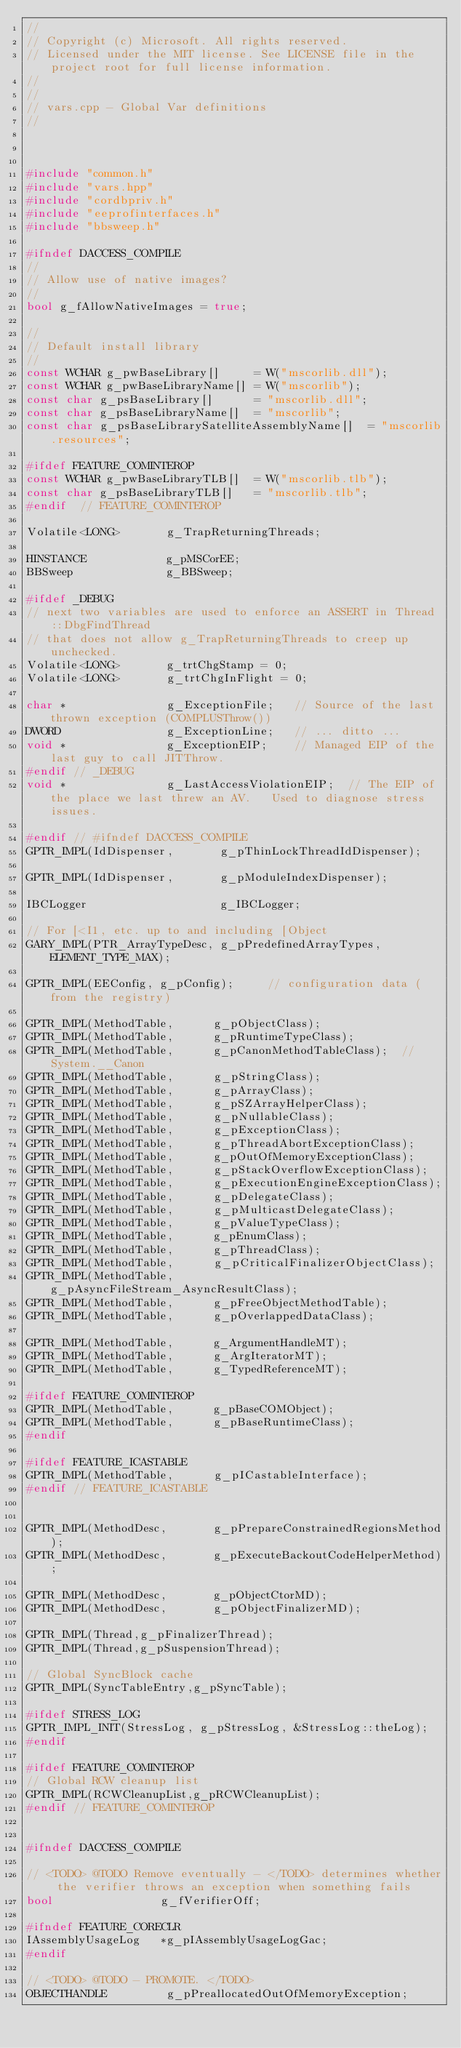Convert code to text. <code><loc_0><loc_0><loc_500><loc_500><_C++_>//
// Copyright (c) Microsoft. All rights reserved.
// Licensed under the MIT license. See LICENSE file in the project root for full license information.
//
//
// vars.cpp - Global Var definitions
//



#include "common.h"
#include "vars.hpp"
#include "cordbpriv.h"
#include "eeprofinterfaces.h"
#include "bbsweep.h"

#ifndef DACCESS_COMPILE
//
// Allow use of native images?
//
bool g_fAllowNativeImages = true;

//
// Default install library
//
const WCHAR g_pwBaseLibrary[]     = W("mscorlib.dll");
const WCHAR g_pwBaseLibraryName[] = W("mscorlib");
const char g_psBaseLibrary[]      = "mscorlib.dll";
const char g_psBaseLibraryName[]  = "mscorlib";
const char g_psBaseLibrarySatelliteAssemblyName[]  = "mscorlib.resources";

#ifdef FEATURE_COMINTEROP
const WCHAR g_pwBaseLibraryTLB[]  = W("mscorlib.tlb");
const char g_psBaseLibraryTLB[]   = "mscorlib.tlb";
#endif  // FEATURE_COMINTEROP

Volatile<LONG>       g_TrapReturningThreads;

HINSTANCE            g_pMSCorEE;
BBSweep              g_BBSweep;

#ifdef _DEBUG
// next two variables are used to enforce an ASSERT in Thread::DbgFindThread
// that does not allow g_TrapReturningThreads to creep up unchecked.
Volatile<LONG>       g_trtChgStamp = 0;
Volatile<LONG>       g_trtChgInFlight = 0;

char *               g_ExceptionFile;   // Source of the last thrown exception (COMPLUSThrow())
DWORD                g_ExceptionLine;   // ... ditto ...
void *               g_ExceptionEIP;    // Managed EIP of the last guy to call JITThrow.
#endif // _DEBUG
void *               g_LastAccessViolationEIP;  // The EIP of the place we last threw an AV.   Used to diagnose stress issues.  

#endif // #ifndef DACCESS_COMPILE
GPTR_IMPL(IdDispenser,       g_pThinLockThreadIdDispenser);

GPTR_IMPL(IdDispenser,       g_pModuleIndexDispenser);

IBCLogger                    g_IBCLogger;

// For [<I1, etc. up to and including [Object
GARY_IMPL(PTR_ArrayTypeDesc, g_pPredefinedArrayTypes, ELEMENT_TYPE_MAX);

GPTR_IMPL(EEConfig, g_pConfig);     // configuration data (from the registry)

GPTR_IMPL(MethodTable,      g_pObjectClass);
GPTR_IMPL(MethodTable,      g_pRuntimeTypeClass);
GPTR_IMPL(MethodTable,      g_pCanonMethodTableClass);  // System.__Canon
GPTR_IMPL(MethodTable,      g_pStringClass);
GPTR_IMPL(MethodTable,      g_pArrayClass);
GPTR_IMPL(MethodTable,      g_pSZArrayHelperClass);
GPTR_IMPL(MethodTable,      g_pNullableClass);
GPTR_IMPL(MethodTable,      g_pExceptionClass);
GPTR_IMPL(MethodTable,      g_pThreadAbortExceptionClass);
GPTR_IMPL(MethodTable,      g_pOutOfMemoryExceptionClass);
GPTR_IMPL(MethodTable,      g_pStackOverflowExceptionClass);
GPTR_IMPL(MethodTable,      g_pExecutionEngineExceptionClass);
GPTR_IMPL(MethodTable,      g_pDelegateClass);
GPTR_IMPL(MethodTable,      g_pMulticastDelegateClass);
GPTR_IMPL(MethodTable,      g_pValueTypeClass);
GPTR_IMPL(MethodTable,      g_pEnumClass);
GPTR_IMPL(MethodTable,      g_pThreadClass);
GPTR_IMPL(MethodTable,      g_pCriticalFinalizerObjectClass);
GPTR_IMPL(MethodTable,      g_pAsyncFileStream_AsyncResultClass);
GPTR_IMPL(MethodTable,      g_pFreeObjectMethodTable);
GPTR_IMPL(MethodTable,      g_pOverlappedDataClass);

GPTR_IMPL(MethodTable,      g_ArgumentHandleMT);
GPTR_IMPL(MethodTable,      g_ArgIteratorMT);
GPTR_IMPL(MethodTable,      g_TypedReferenceMT);

#ifdef FEATURE_COMINTEROP
GPTR_IMPL(MethodTable,      g_pBaseCOMObject);
GPTR_IMPL(MethodTable,      g_pBaseRuntimeClass);
#endif

#ifdef FEATURE_ICASTABLE
GPTR_IMPL(MethodTable,      g_pICastableInterface);
#endif // FEATURE_ICASTABLE


GPTR_IMPL(MethodDesc,       g_pPrepareConstrainedRegionsMethod);
GPTR_IMPL(MethodDesc,       g_pExecuteBackoutCodeHelperMethod);

GPTR_IMPL(MethodDesc,       g_pObjectCtorMD);
GPTR_IMPL(MethodDesc,       g_pObjectFinalizerMD);

GPTR_IMPL(Thread,g_pFinalizerThread);
GPTR_IMPL(Thread,g_pSuspensionThread);

// Global SyncBlock cache
GPTR_IMPL(SyncTableEntry,g_pSyncTable);

#ifdef STRESS_LOG
GPTR_IMPL_INIT(StressLog, g_pStressLog, &StressLog::theLog);
#endif

#ifdef FEATURE_COMINTEROP
// Global RCW cleanup list
GPTR_IMPL(RCWCleanupList,g_pRCWCleanupList);
#endif // FEATURE_COMINTEROP


#ifndef DACCESS_COMPILE

// <TODO> @TODO Remove eventually - </TODO> determines whether the verifier throws an exception when something fails
bool                g_fVerifierOff;

#ifndef FEATURE_CORECLR
IAssemblyUsageLog   *g_pIAssemblyUsageLogGac;
#endif

// <TODO> @TODO - PROMOTE. </TODO>
OBJECTHANDLE         g_pPreallocatedOutOfMemoryException;</code> 